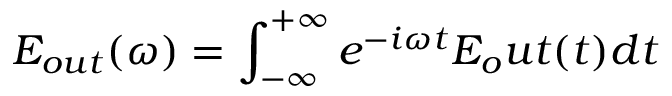Convert formula to latex. <formula><loc_0><loc_0><loc_500><loc_500>E _ { o u t } ( \omega ) = \int _ { - \infty } ^ { + \infty } e ^ { - i \omega t } E _ { o } u t ( t ) d t</formula> 